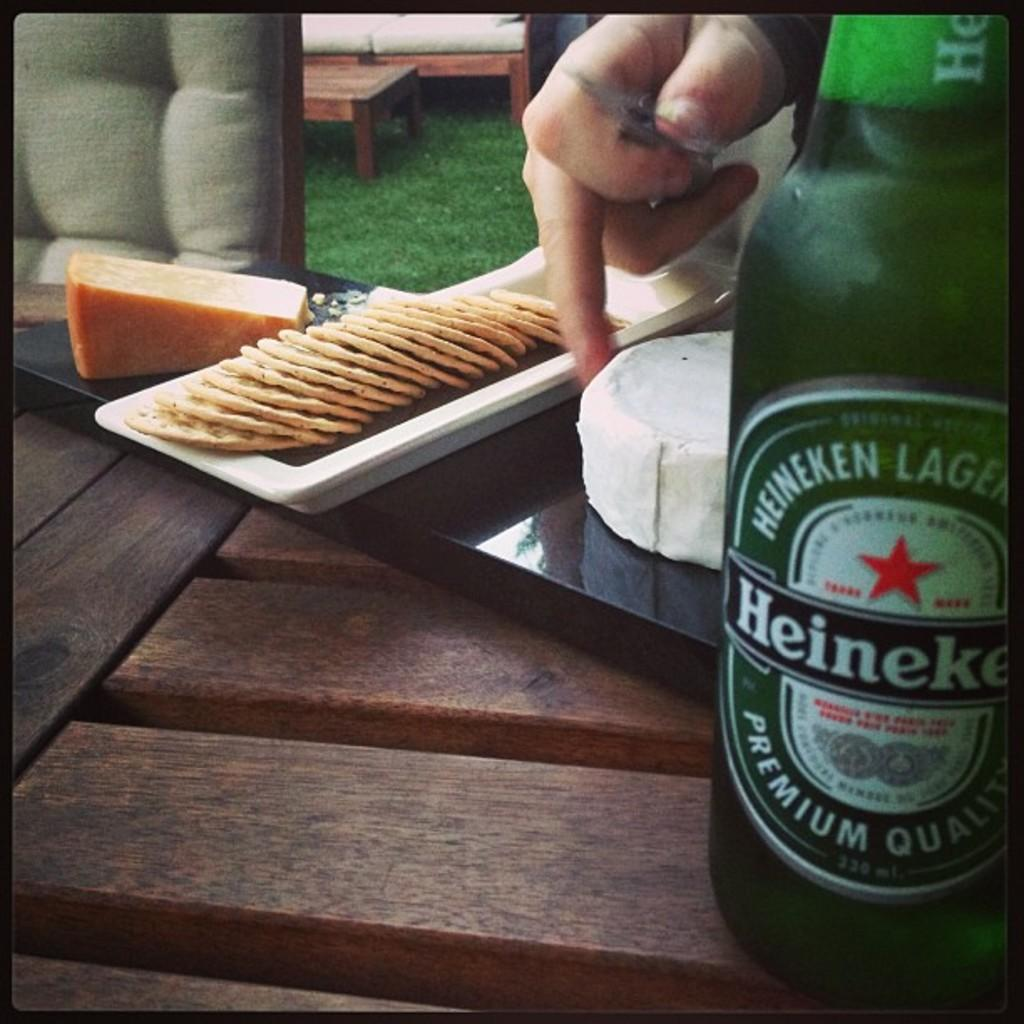<image>
Create a compact narrative representing the image presented. A bottle of Heineken sits near a plate of cheese and crackers 